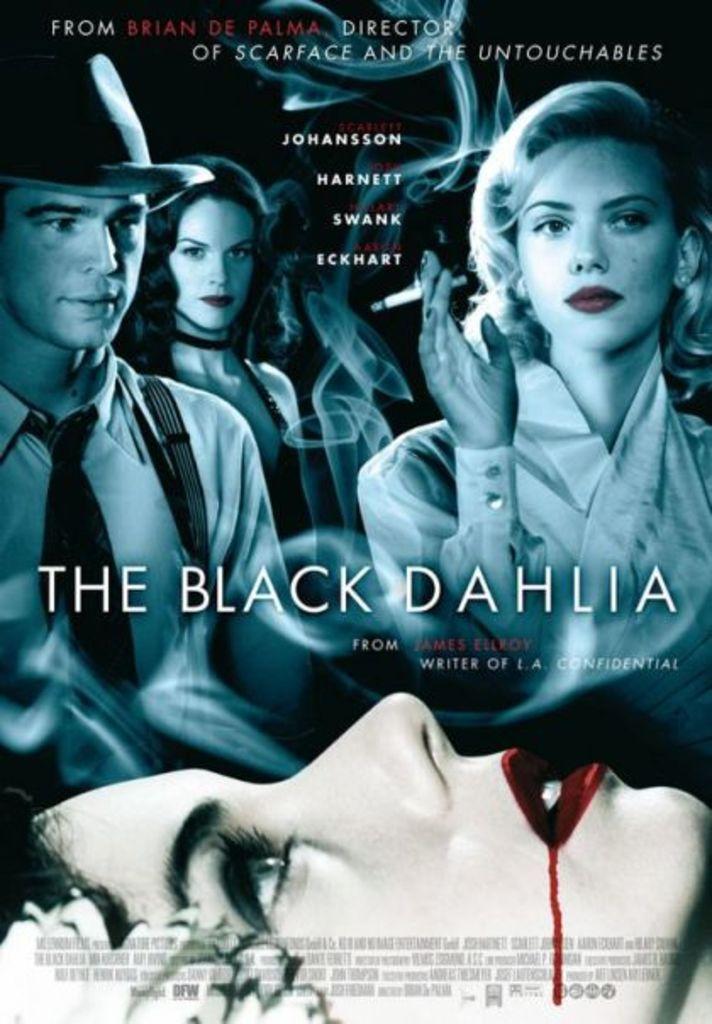What is the title of the work?
Ensure brevity in your answer.  The black dahlia. 